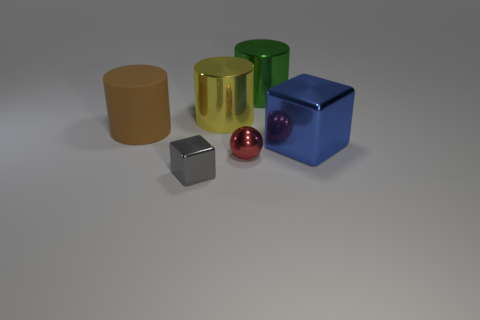Are there any other things that are made of the same material as the large brown cylinder?
Your response must be concise. No. How big is the metallic cube that is to the left of the big yellow metal object?
Ensure brevity in your answer.  Small. Are there any other things of the same color as the sphere?
Your response must be concise. No. There is a cube in front of the big thing in front of the brown rubber thing; are there any green metal objects in front of it?
Offer a terse response. No. Is the color of the metal cube that is to the left of the large blue shiny cube the same as the tiny metal sphere?
Your answer should be compact. No. How many cylinders are either tiny objects or green things?
Provide a succinct answer. 1. There is a tiny object behind the block left of the green metal object; what is its shape?
Your answer should be very brief. Sphere. There is a blue block that is on the right side of the metallic object on the left side of the metal cylinder that is to the left of the sphere; what is its size?
Your answer should be very brief. Large. Is the size of the brown object the same as the yellow thing?
Ensure brevity in your answer.  Yes. What number of things are either brown spheres or cubes?
Offer a terse response. 2. 